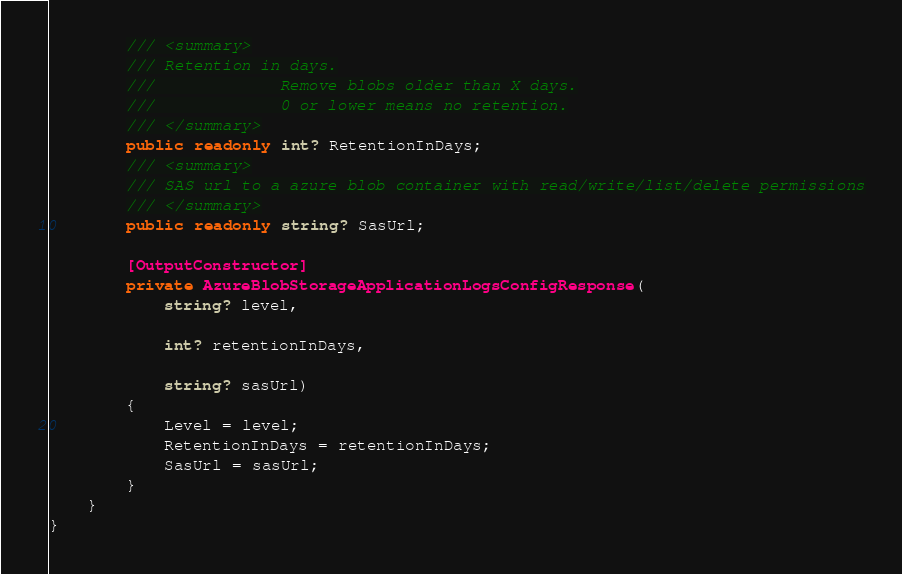Convert code to text. <code><loc_0><loc_0><loc_500><loc_500><_C#_>        /// <summary>
        /// Retention in days.
        ///             Remove blobs older than X days.
        ///             0 or lower means no retention.
        /// </summary>
        public readonly int? RetentionInDays;
        /// <summary>
        /// SAS url to a azure blob container with read/write/list/delete permissions
        /// </summary>
        public readonly string? SasUrl;

        [OutputConstructor]
        private AzureBlobStorageApplicationLogsConfigResponse(
            string? level,

            int? retentionInDays,

            string? sasUrl)
        {
            Level = level;
            RetentionInDays = retentionInDays;
            SasUrl = sasUrl;
        }
    }
}
</code> 